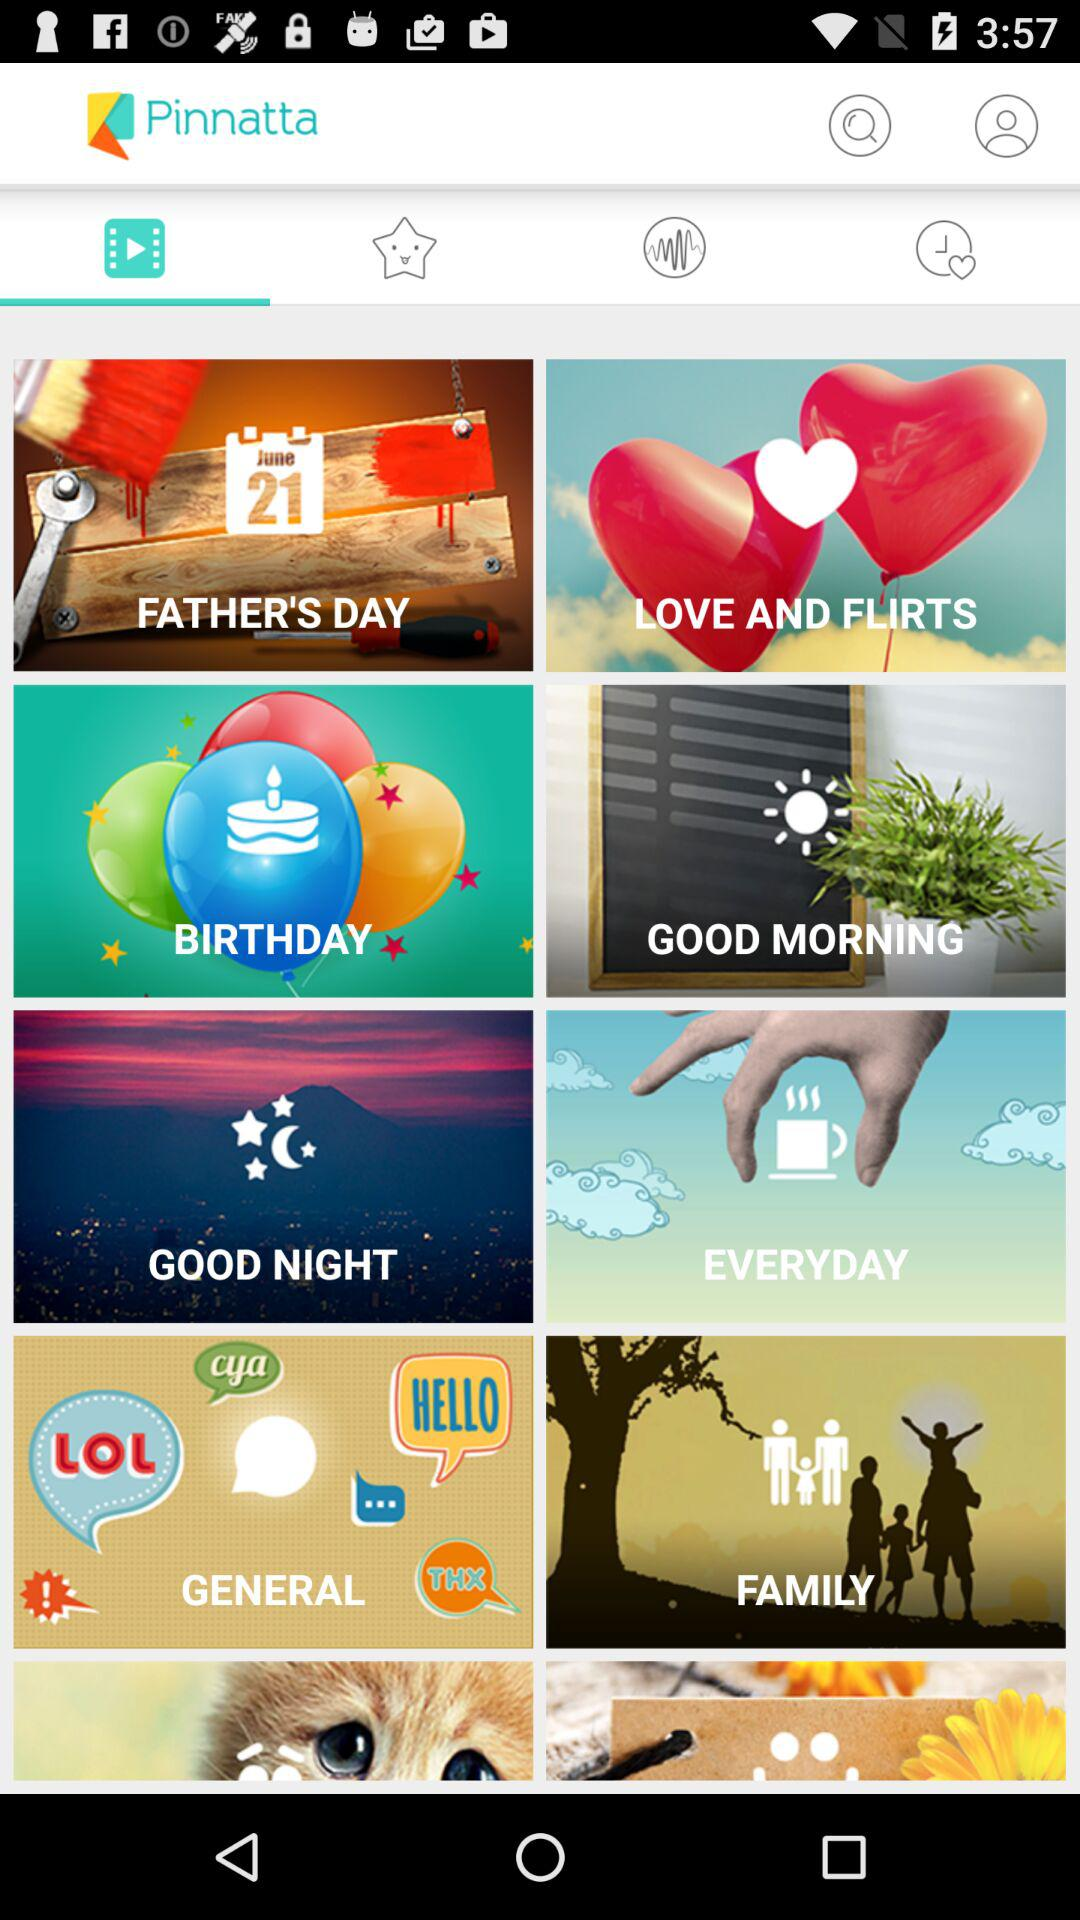What is the name of the application? The name of the application is "Pinnatta". 